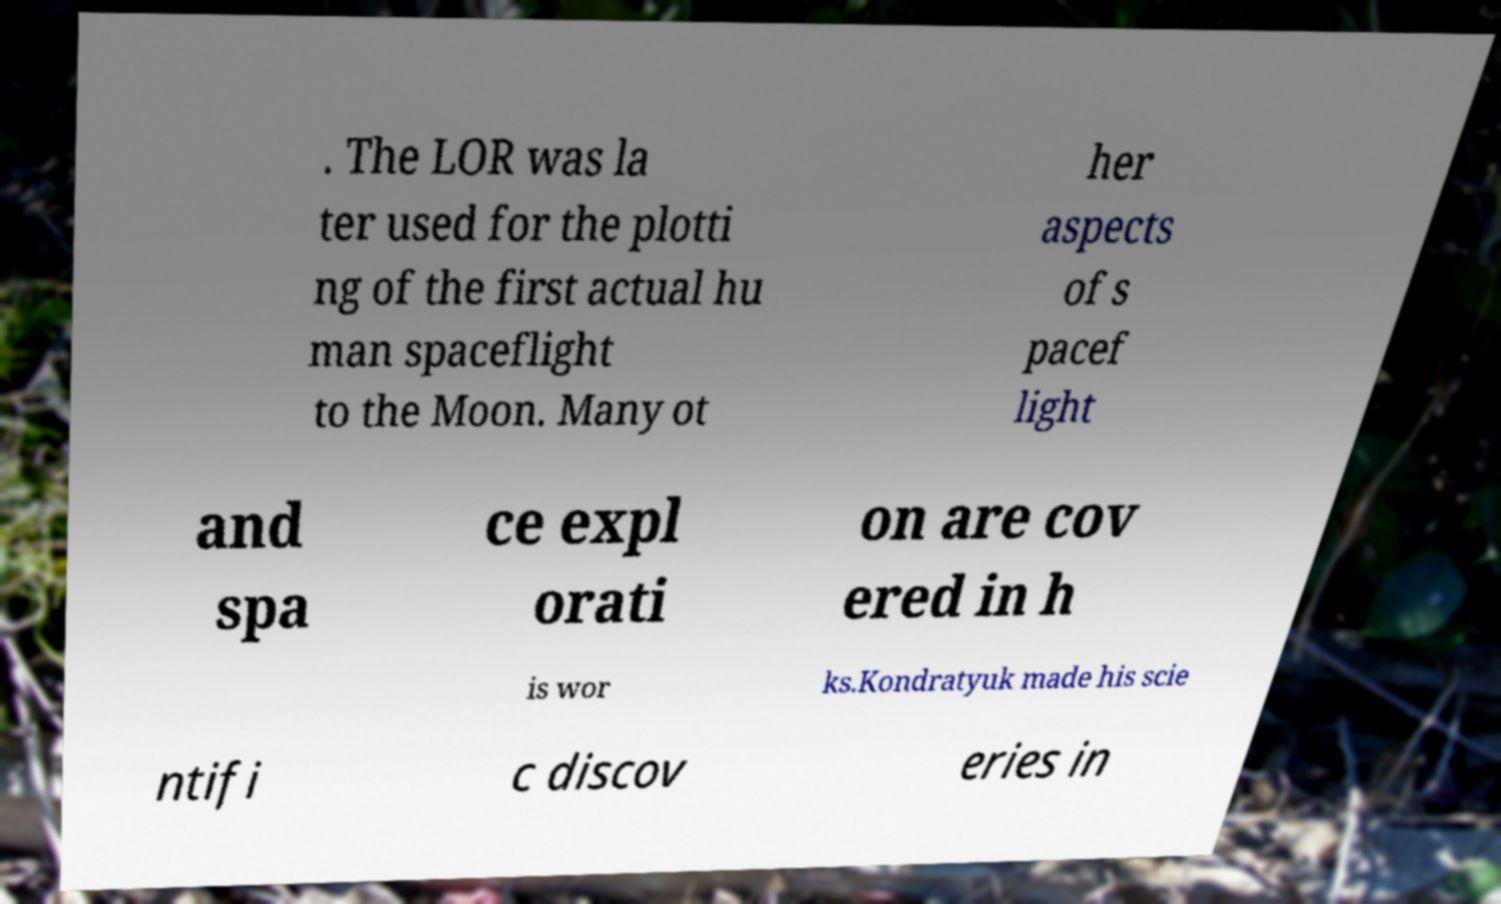Can you read and provide the text displayed in the image?This photo seems to have some interesting text. Can you extract and type it out for me? . The LOR was la ter used for the plotti ng of the first actual hu man spaceflight to the Moon. Many ot her aspects of s pacef light and spa ce expl orati on are cov ered in h is wor ks.Kondratyuk made his scie ntifi c discov eries in 